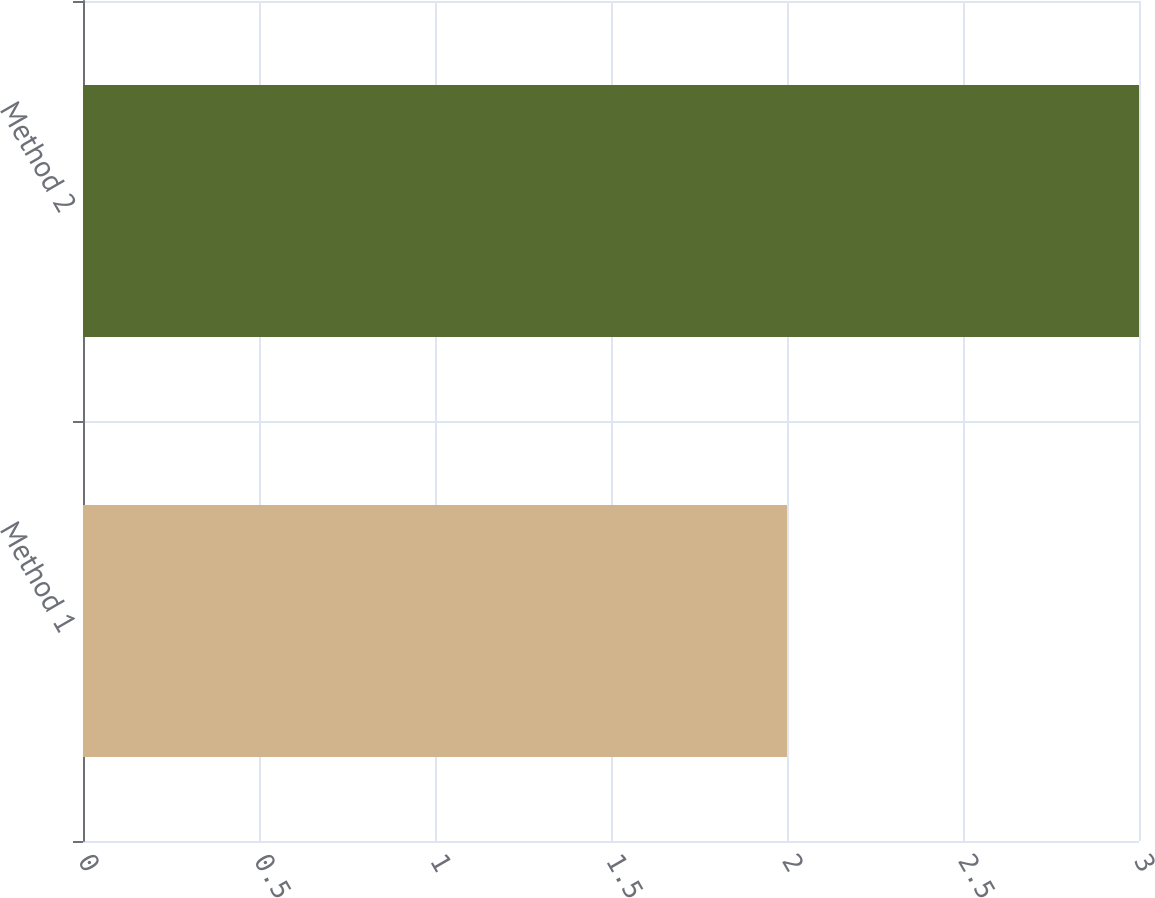Convert chart to OTSL. <chart><loc_0><loc_0><loc_500><loc_500><bar_chart><fcel>Method 1<fcel>Method 2<nl><fcel>2<fcel>3<nl></chart> 